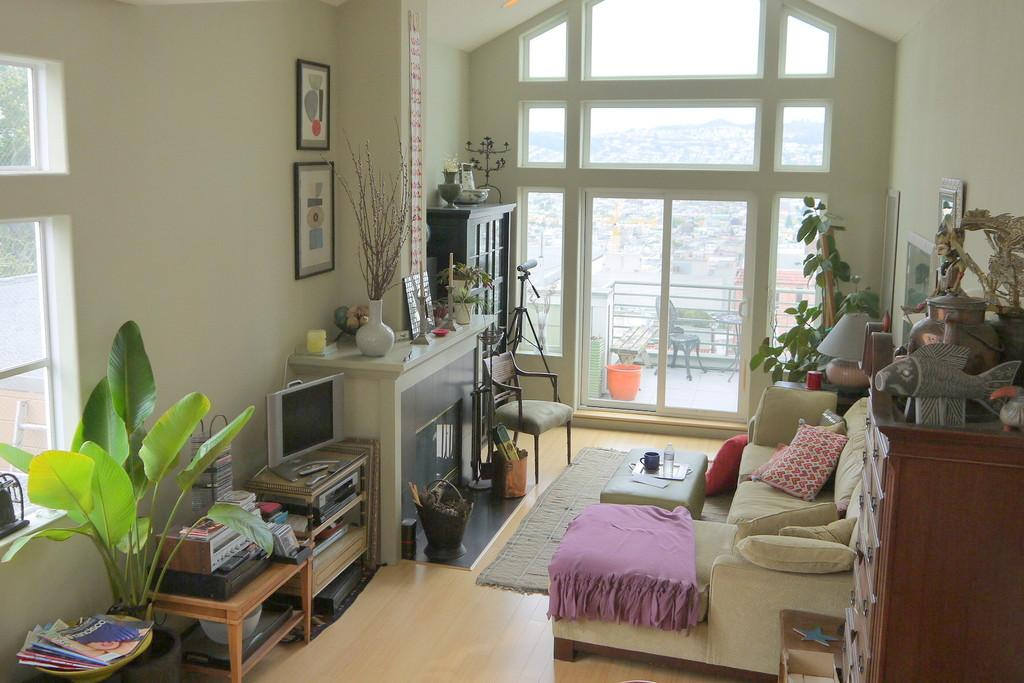What type of furniture is present in the image? There is a sofa, a chair, and tables in the image. What can be found on the sofa? There are cushions on the sofa. What type of decorative items are present in the image? There are plants, frames on the wall, and a television in the image. What type of lighting is present in the image? There is a lamp in the image. How many legs can be seen on the wish in the image? There is no wish present in the image, so it is not possible to determine the number of legs. 